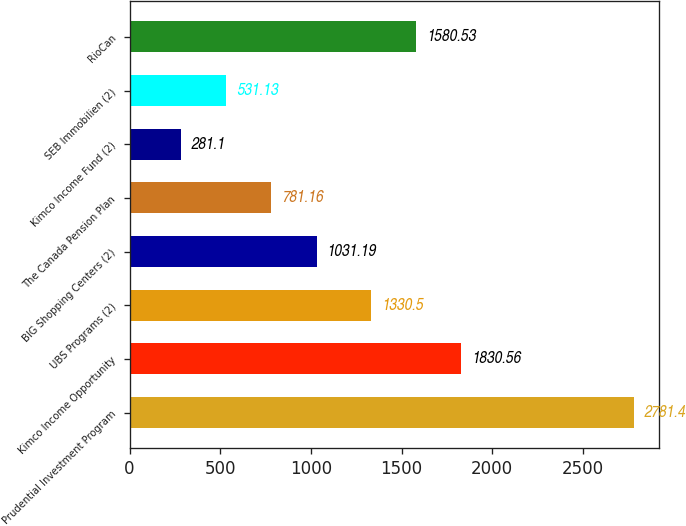<chart> <loc_0><loc_0><loc_500><loc_500><bar_chart><fcel>Prudential Investment Program<fcel>Kimco Income Opportunity<fcel>UBS Programs (2)<fcel>BIG Shopping Centers (2)<fcel>The Canada Pension Plan<fcel>Kimco Income Fund (2)<fcel>SEB Immobilien (2)<fcel>RioCan<nl><fcel>2781.4<fcel>1830.56<fcel>1330.5<fcel>1031.19<fcel>781.16<fcel>281.1<fcel>531.13<fcel>1580.53<nl></chart> 